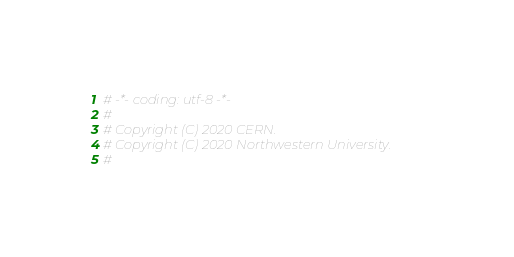Convert code to text. <code><loc_0><loc_0><loc_500><loc_500><_Python_># -*- coding: utf-8 -*-
#
# Copyright (C) 2020 CERN.
# Copyright (C) 2020 Northwestern University.
#</code> 